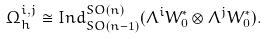Convert formula to latex. <formula><loc_0><loc_0><loc_500><loc_500>\Omega _ { h } ^ { i , j } \cong I n d _ { S O ( n - 1 ) } ^ { S O ( n ) } ( \Lambda ^ { i } W _ { 0 } ^ { * } \otimes \Lambda ^ { j } W _ { 0 } ^ { * } ) .</formula> 